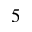Convert formula to latex. <formula><loc_0><loc_0><loc_500><loc_500>5</formula> 